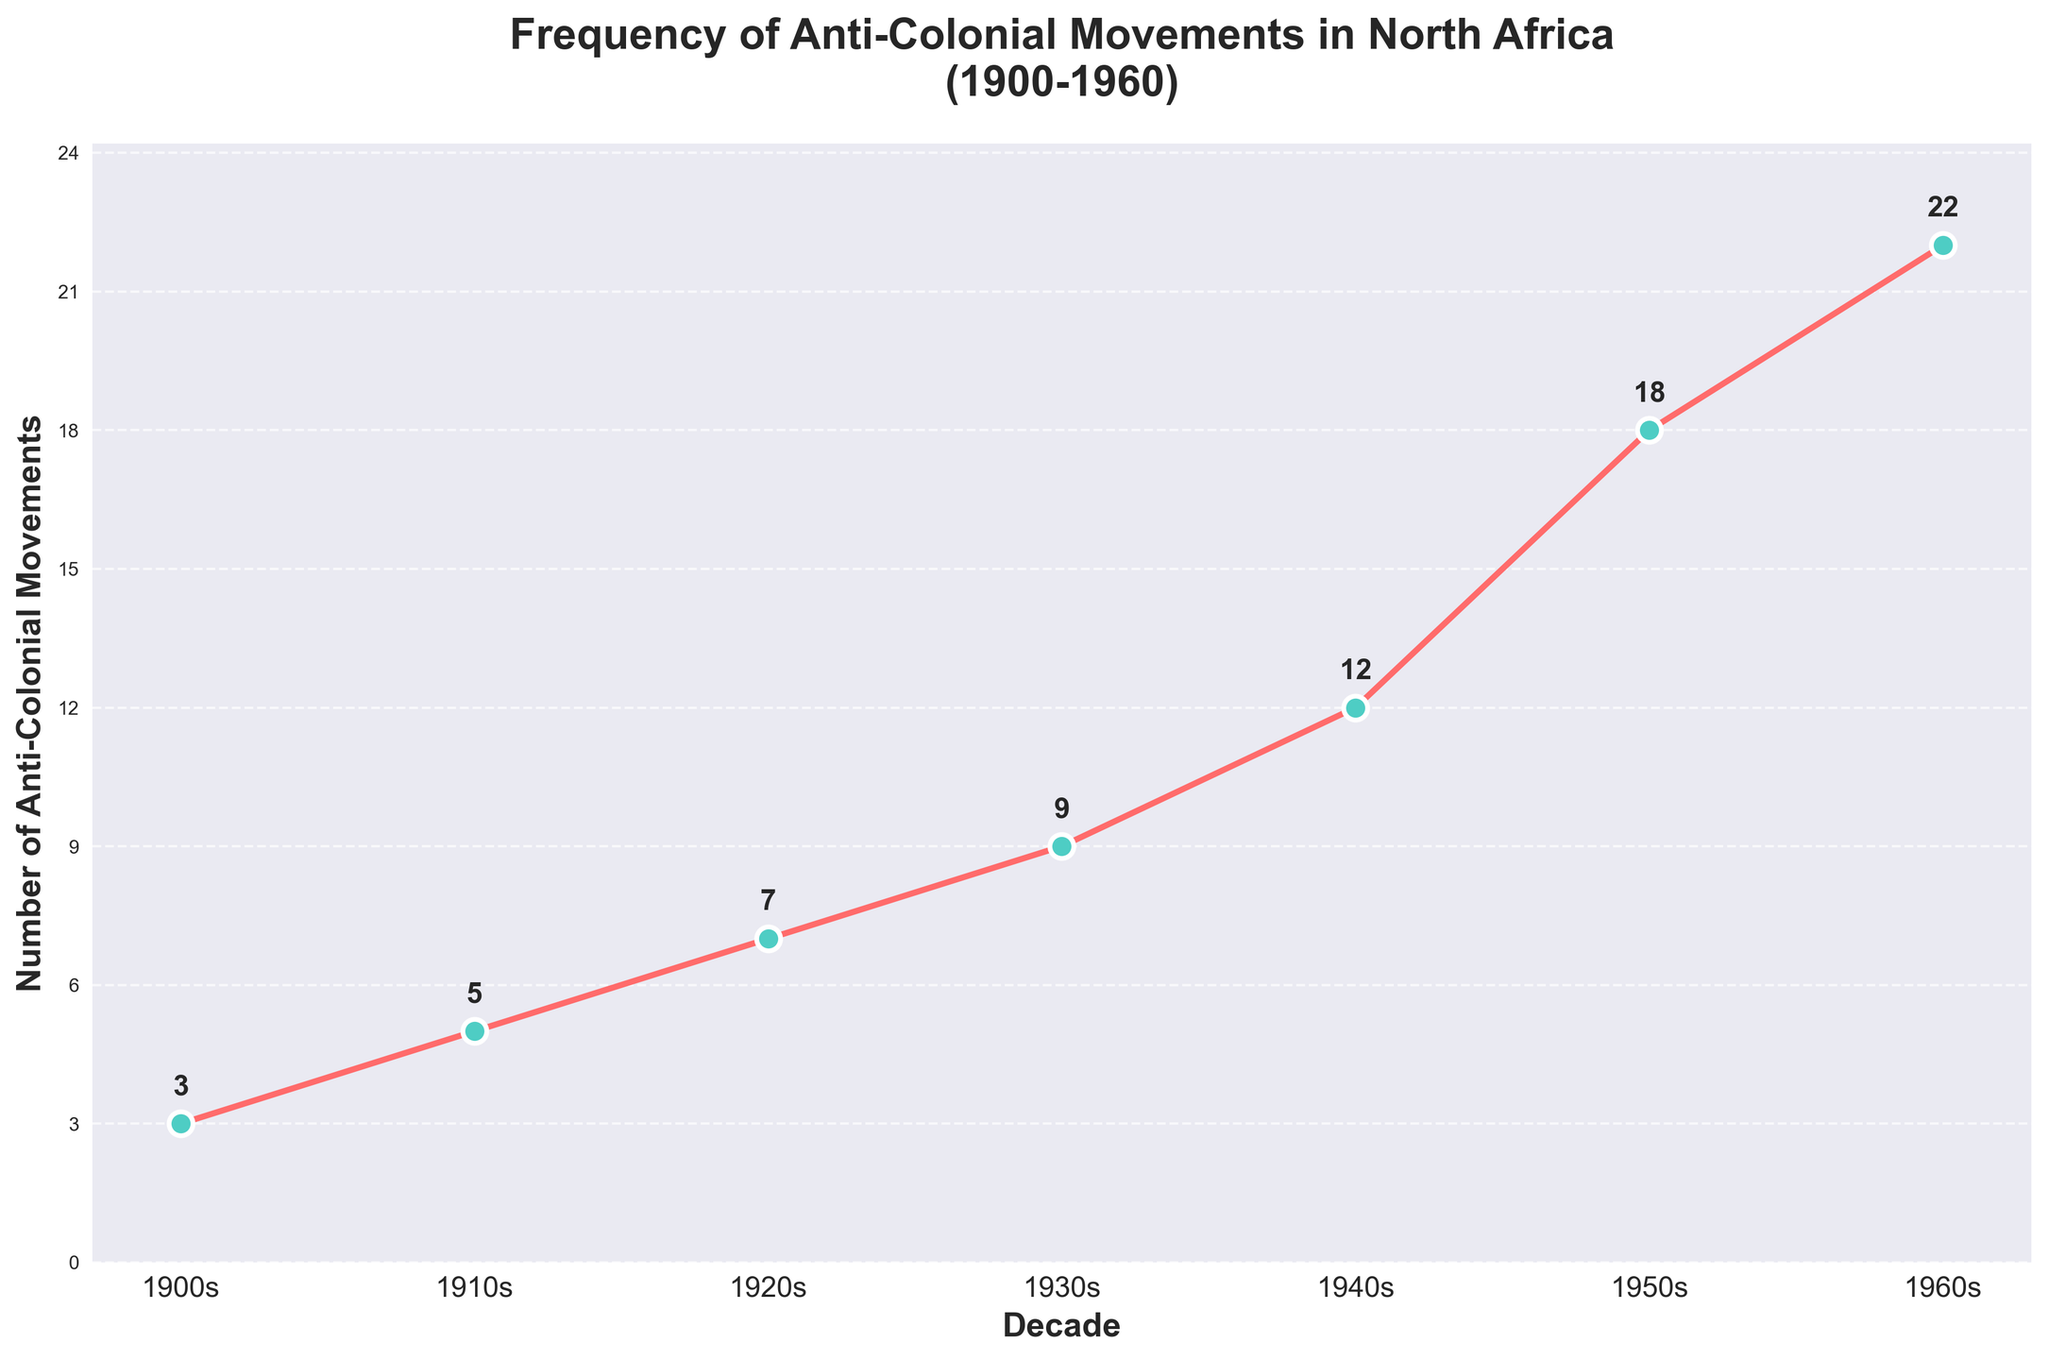What is the title of the chart? The title is usually displayed prominently at the top of a chart and summarizes the main information being presented.
Answer: Frequency of Anti-Colonial Movements in North Africa (1900-1960) What is depicted on the x-axis? The x-axis represents the independent variable and is labeled to show what it measures. In this chart, it represents time in decades.
Answer: Decade What is depicted on the y-axis? The y-axis represents the dependent variable and is labeled to show what it measures. In this chart, it represents the number of anti-colonial movements.
Answer: Number of Anti-Colonial Movements How many anti-colonial movements were recorded in the 1940s? You can identify the count for the 1940s by locating the corresponding point on the line plot and reading the y-axis value or the data label.
Answer: 12 Which decade had the highest number of anti-colonial movements? To find the decade with the highest number of movements, look for the point which is the highest on the y-axis.
Answer: 1960s What is the increase in the number of movements from the 1900s to the 1960s? Subtract the number of movements in the 1900s from the number of movements in the 1960s.
Answer: 22 - 3 = 19 What has been the general trend in the frequency of anti-colonial movements from 1900 to 1960? Observe the overall direction of the line plot from 1900 to 1960. The line generally slopes upwards, indicating a rising trend.
Answer: Increasing Which decades show an increase of exactly 2 movements compared to the previous decade? By examining the differences between consecutive decades: 1910s (5) - 1900s (3) = 2; 1920s (7) - 1910s (5) = 2.
Answer: 1910s and 1920s Between which consecutive decades did the frequency of anti-colonial movements increase the most? Compare the differences between each consecutive decade: e.g., 1950s to 1960s is 22 - 18 = 4, which is the highest observed change.
Answer: 1940s to 1950s What is the average number of anti-colonial movements per decade over the entire period? Sum the total number of movements and divide by the number of decades: (3 + 5 + 7 + 9 + 12 + 18 + 22) / 7 = 11.71
Answer: 11.71 